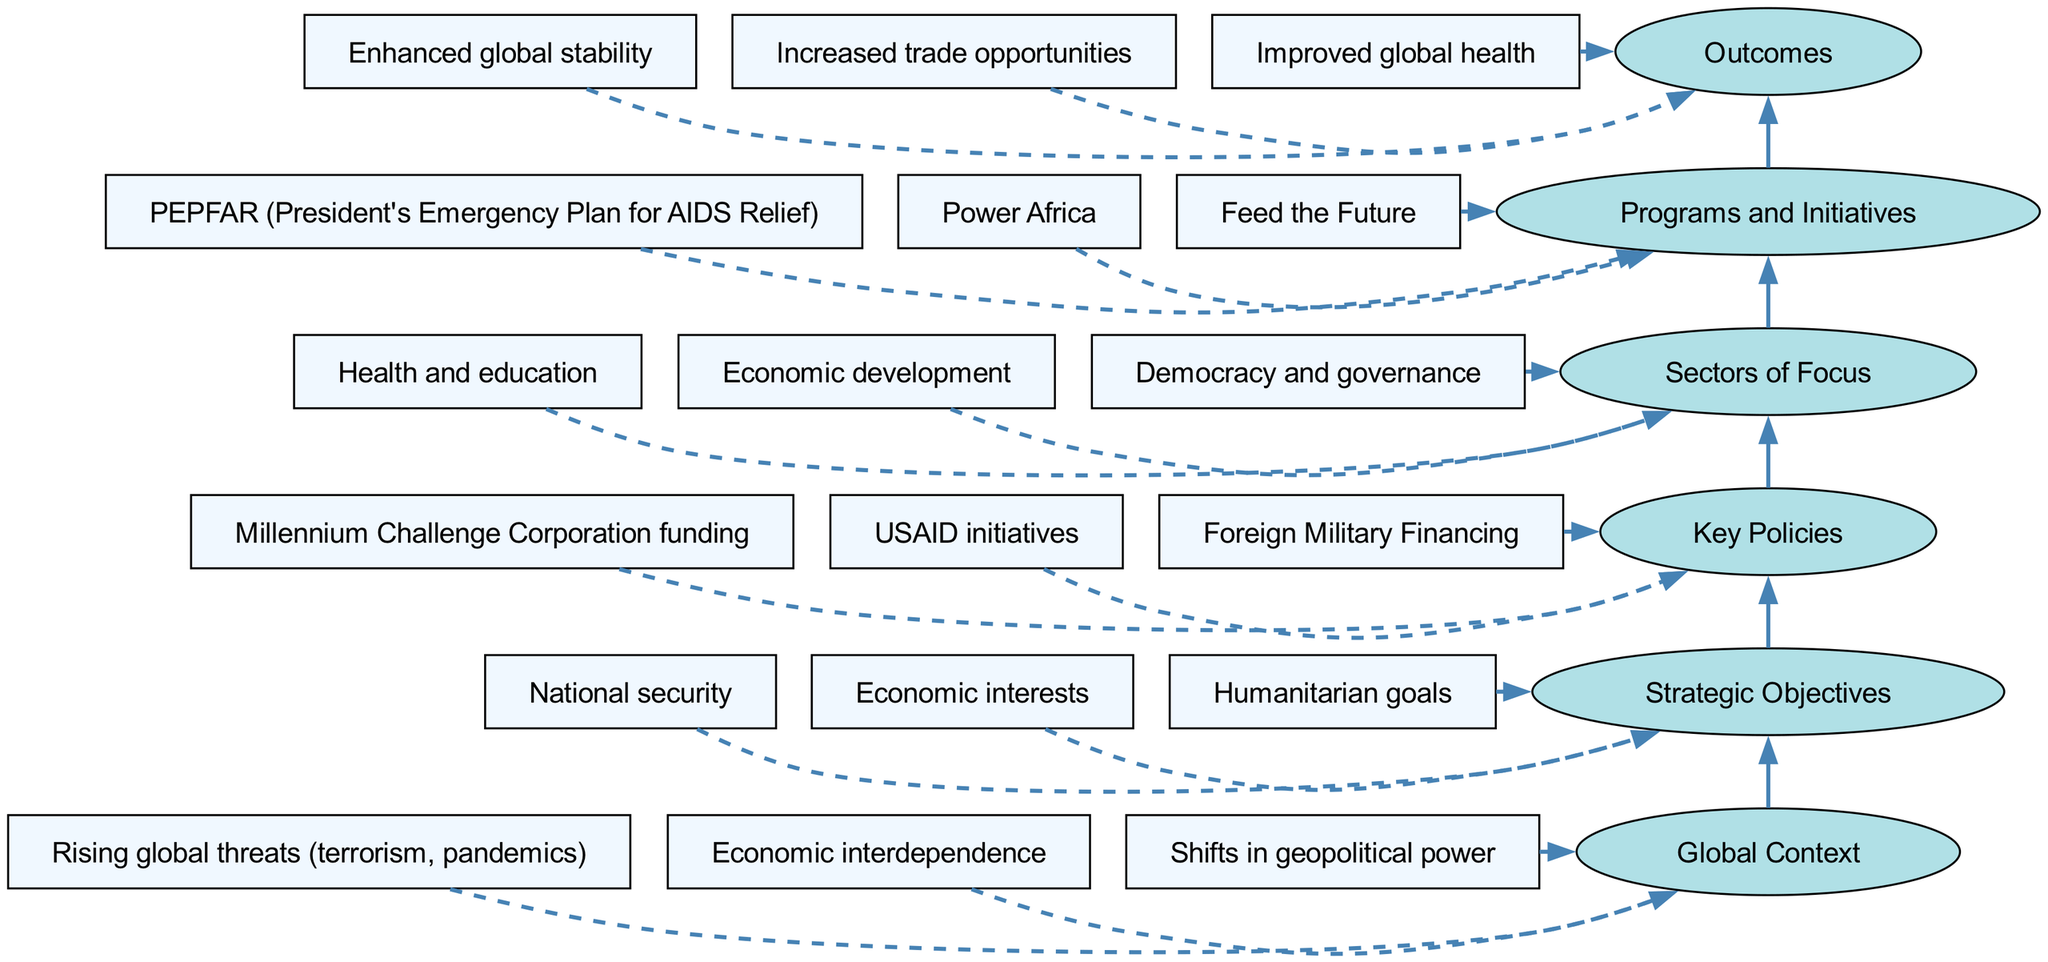What is the highest level in the diagram? The highest level in the diagram is labeled "Outcomes", which is located at the top of the flow chart.
Answer: Outcomes How many sectors of focus are listed in the diagram? The diagram indicates three sectors of focus listed under "Sectors of Focus". They are health and education, economic development, and democracy and governance.
Answer: Three What is one key policy mentioned in the diagram? One of the key policies mentioned in the diagram is "USAID initiatives", which is found in the "Key Policies" section.
Answer: USAID initiatives Which program is related to global health? The program "PEPFAR" (President's Emergency Plan for AIDS Relief) is related to global health and is listed under "Programs and Initiatives".
Answer: PEPFAR How do the "Strategic Objectives" relate to "Outcomes"? The flow from "Strategic Objectives" to "Outcomes" indicates that the strategic objectives such as national security, economic interests, and humanitarian goals serve to enhance global stability, increase trade opportunities, and improve global health.
Answer: Enhanced global stability, increased trade opportunities, improved global health What is the first step in achieving U.S. foreign aid outcomes? The first step in achieving outcomes, as represented in the flow chart, is establishing strategic objectives, which consists of national security, economic interests, and humanitarian goals.
Answer: Strategic Objectives Which level contains "Economic interdependence"? "Economic interdependence" is found in the "Global Context", which is the bottom level of the diagram.
Answer: Global Context What program focuses on addressing food security? The program "Feed the Future" focuses on addressing food security, and is cited under "Programs and Initiatives".
Answer: Feed the Future Which outcome is linked to improved global health? The outcome directly linked to improved global health is found under "Outcomes", which lists this as one of the main results of U.S. foreign aid strategy.
Answer: Improved global health 